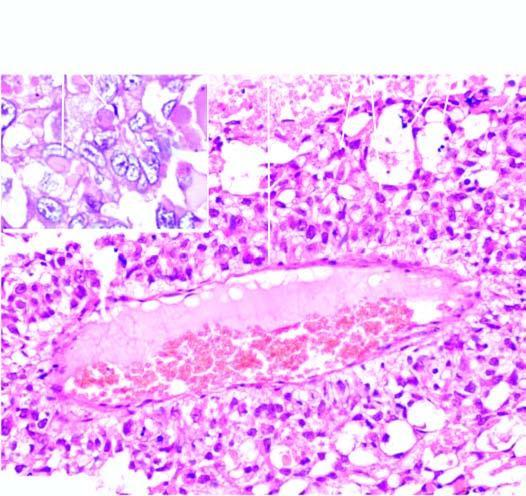does epra bacilli in ll seen in fite-faraco show intra - and extracellular hyaline globules?
Answer the question using a single word or phrase. No 